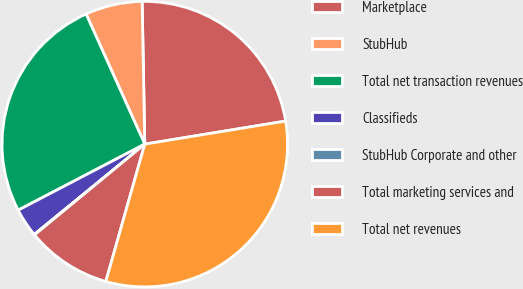Convert chart to OTSL. <chart><loc_0><loc_0><loc_500><loc_500><pie_chart><fcel>Marketplace<fcel>StubHub<fcel>Total net transaction revenues<fcel>Classifieds<fcel>StubHub Corporate and other<fcel>Total marketing services and<fcel>Total net revenues<nl><fcel>22.71%<fcel>6.45%<fcel>25.91%<fcel>3.25%<fcel>0.06%<fcel>9.64%<fcel>31.98%<nl></chart> 